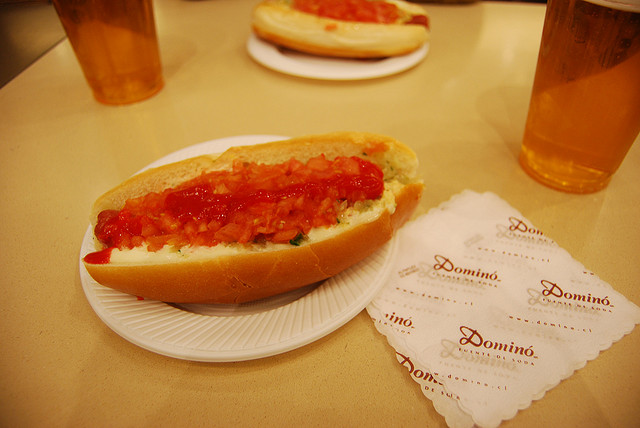Please transcribe the text in this image. Domino Domino Dom Domino ino ino Domino 